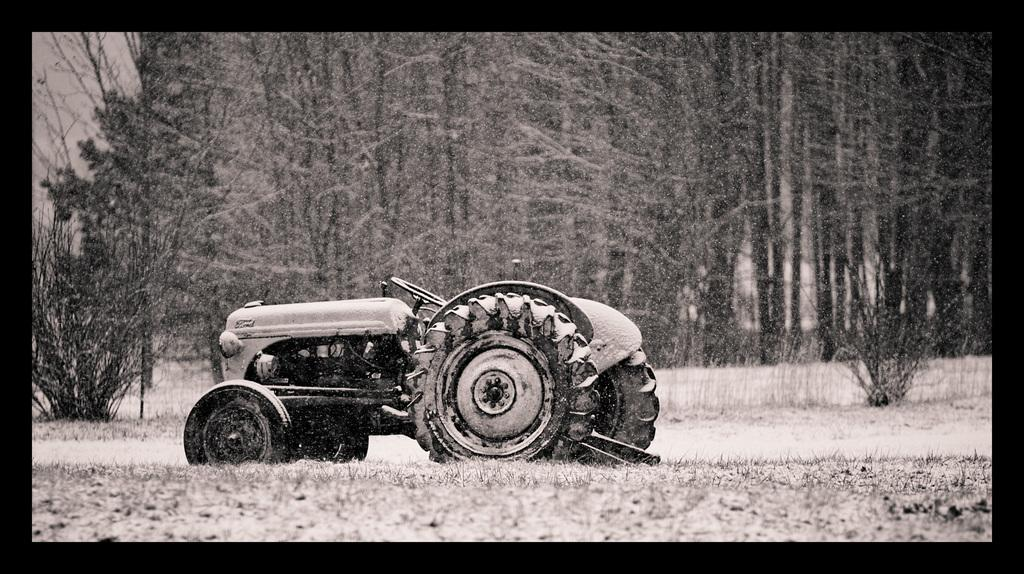What type of vegetation can be seen in the image? There are trees, grass, and plants in the image. What else is present in the image besides vegetation? There is a vehicle in the image. Can you see any receipts lying on the ground in the image? There are no receipts present in the image. How many babies are visible in the image? There are no babies present in the image. 